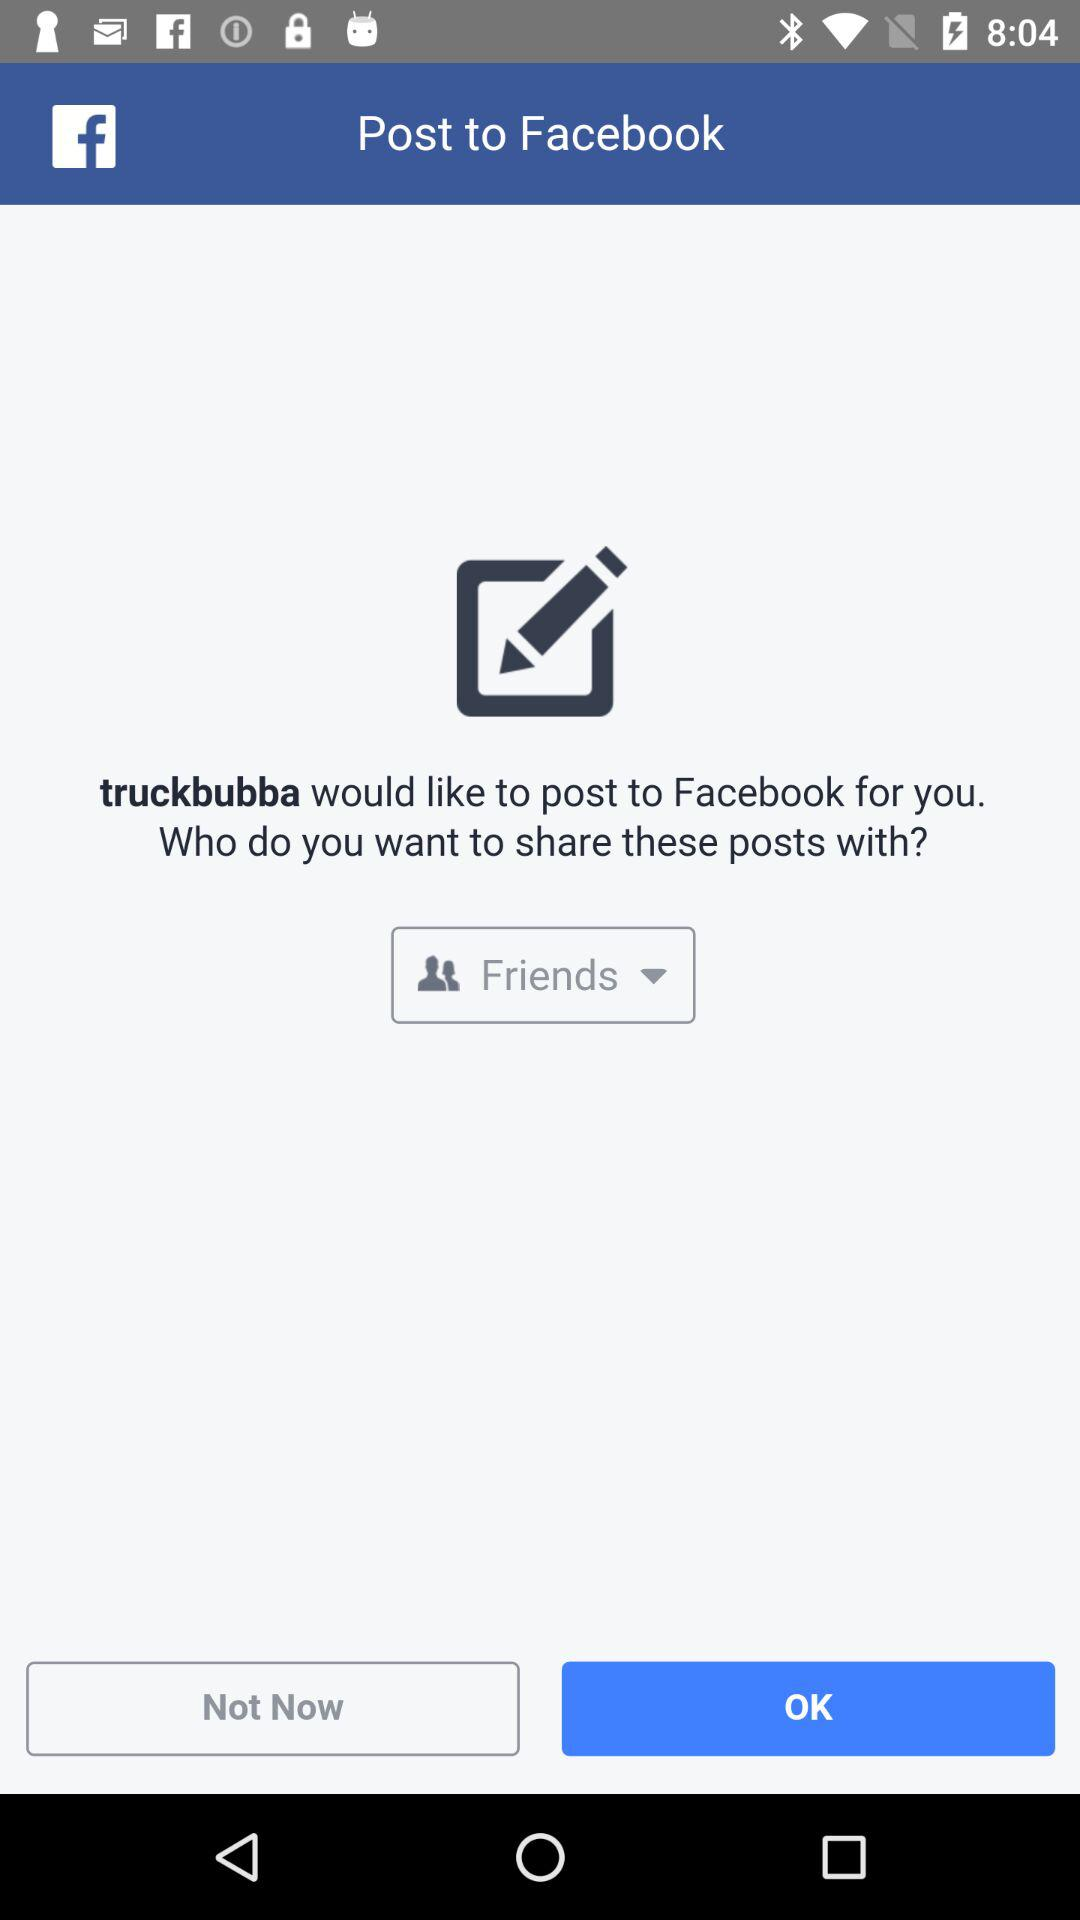What application is asking for permission? The application is "truckbubba". 